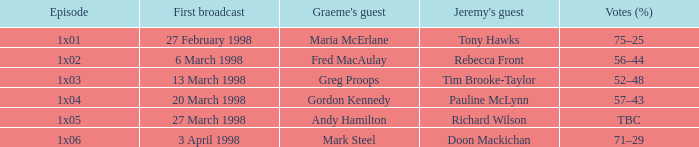Can you identify graeme's guest in the "1x03" episode? Greg Proops. 